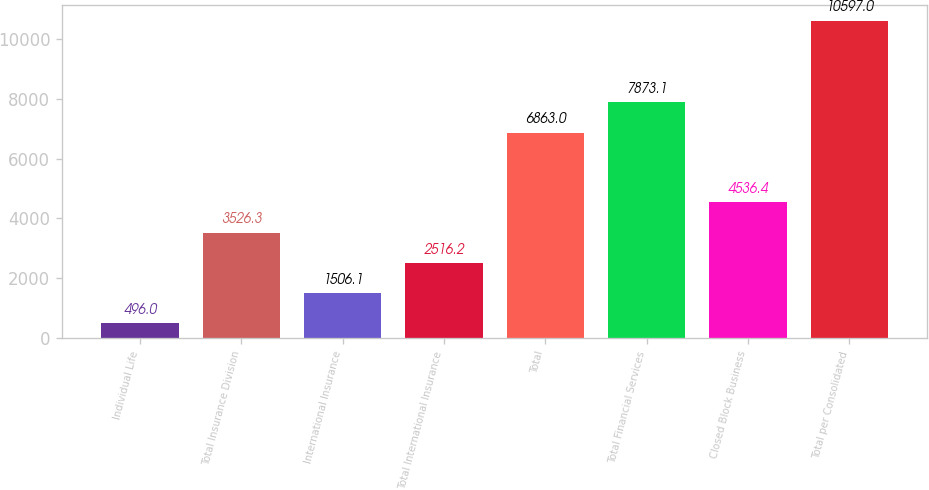<chart> <loc_0><loc_0><loc_500><loc_500><bar_chart><fcel>Individual Life<fcel>Total Insurance Division<fcel>International Insurance<fcel>Total International Insurance<fcel>Total<fcel>Total Financial Services<fcel>Closed Block Business<fcel>Total per Consolidated<nl><fcel>496<fcel>3526.3<fcel>1506.1<fcel>2516.2<fcel>6863<fcel>7873.1<fcel>4536.4<fcel>10597<nl></chart> 